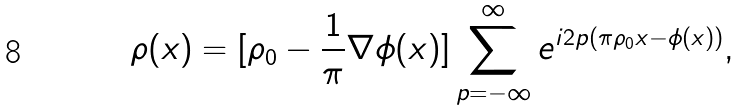<formula> <loc_0><loc_0><loc_500><loc_500>\rho ( x ) = [ \rho _ { 0 } - \frac { 1 } { \pi } \nabla \phi ( x ) ] \sum _ { p = - \infty } ^ { \infty } e ^ { i 2 p ( \pi \rho _ { 0 } x - \phi ( x ) ) } ,</formula> 